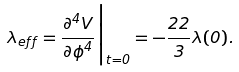Convert formula to latex. <formula><loc_0><loc_0><loc_500><loc_500>\lambda _ { e f f } = \frac { \partial ^ { 4 } V } { \partial \phi ^ { 4 } } \Big | _ { t = 0 } = - \frac { 2 2 } { 3 } \lambda ( 0 ) .</formula> 